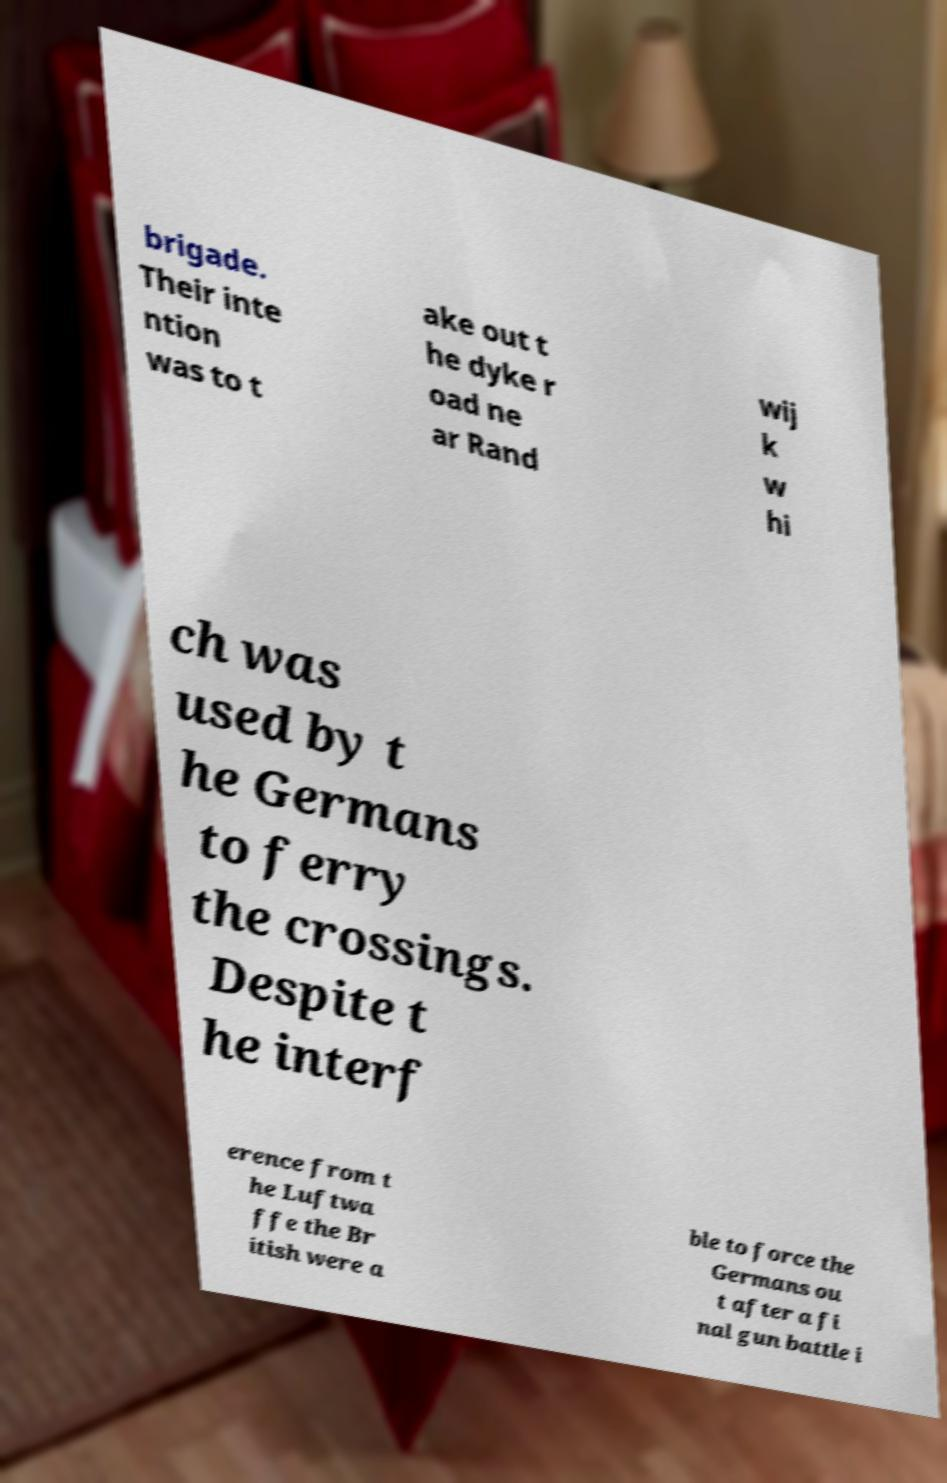There's text embedded in this image that I need extracted. Can you transcribe it verbatim? brigade. Their inte ntion was to t ake out t he dyke r oad ne ar Rand wij k w hi ch was used by t he Germans to ferry the crossings. Despite t he interf erence from t he Luftwa ffe the Br itish were a ble to force the Germans ou t after a fi nal gun battle i 